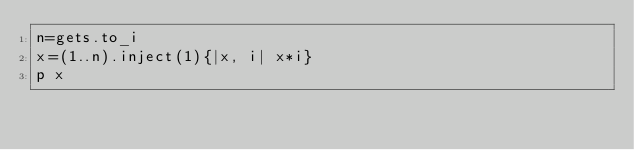<code> <loc_0><loc_0><loc_500><loc_500><_Ruby_>n=gets.to_i
x=(1..n).inject(1){|x, i| x*i}
p x
</code> 